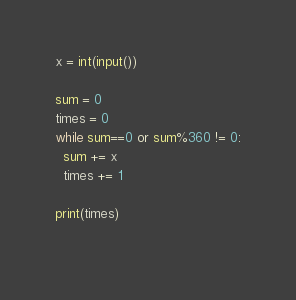Convert code to text. <code><loc_0><loc_0><loc_500><loc_500><_Python_>x = int(input())

sum = 0
times = 0
while sum==0 or sum%360 != 0:
  sum += x
  times += 1

print(times)
  	</code> 